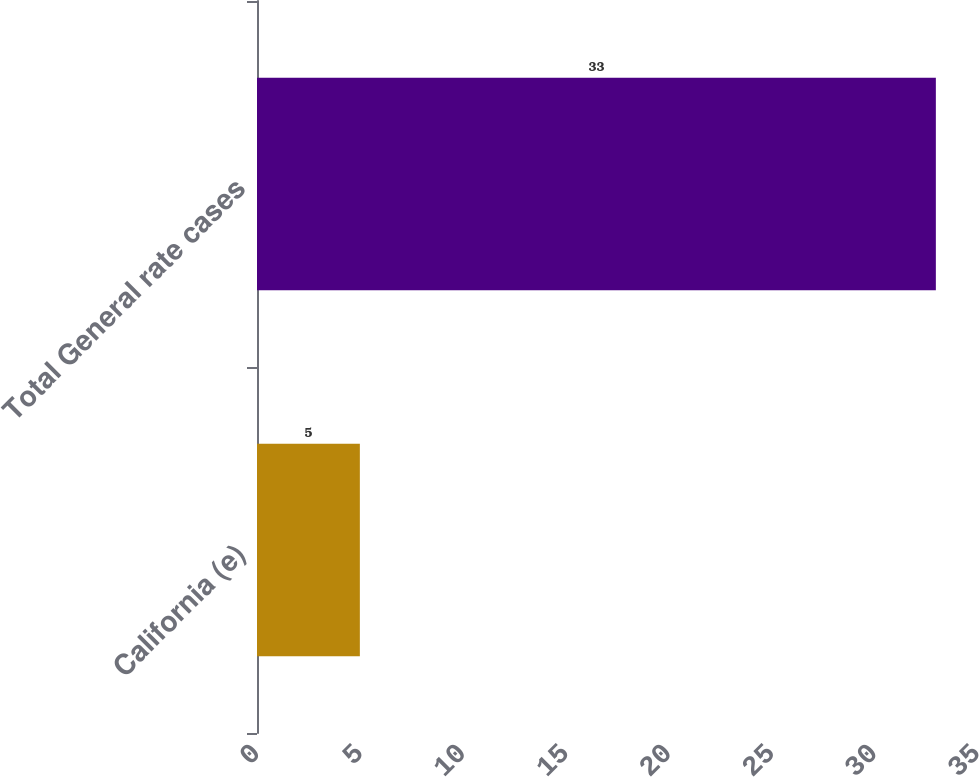<chart> <loc_0><loc_0><loc_500><loc_500><bar_chart><fcel>California (e)<fcel>Total General rate cases<nl><fcel>5<fcel>33<nl></chart> 